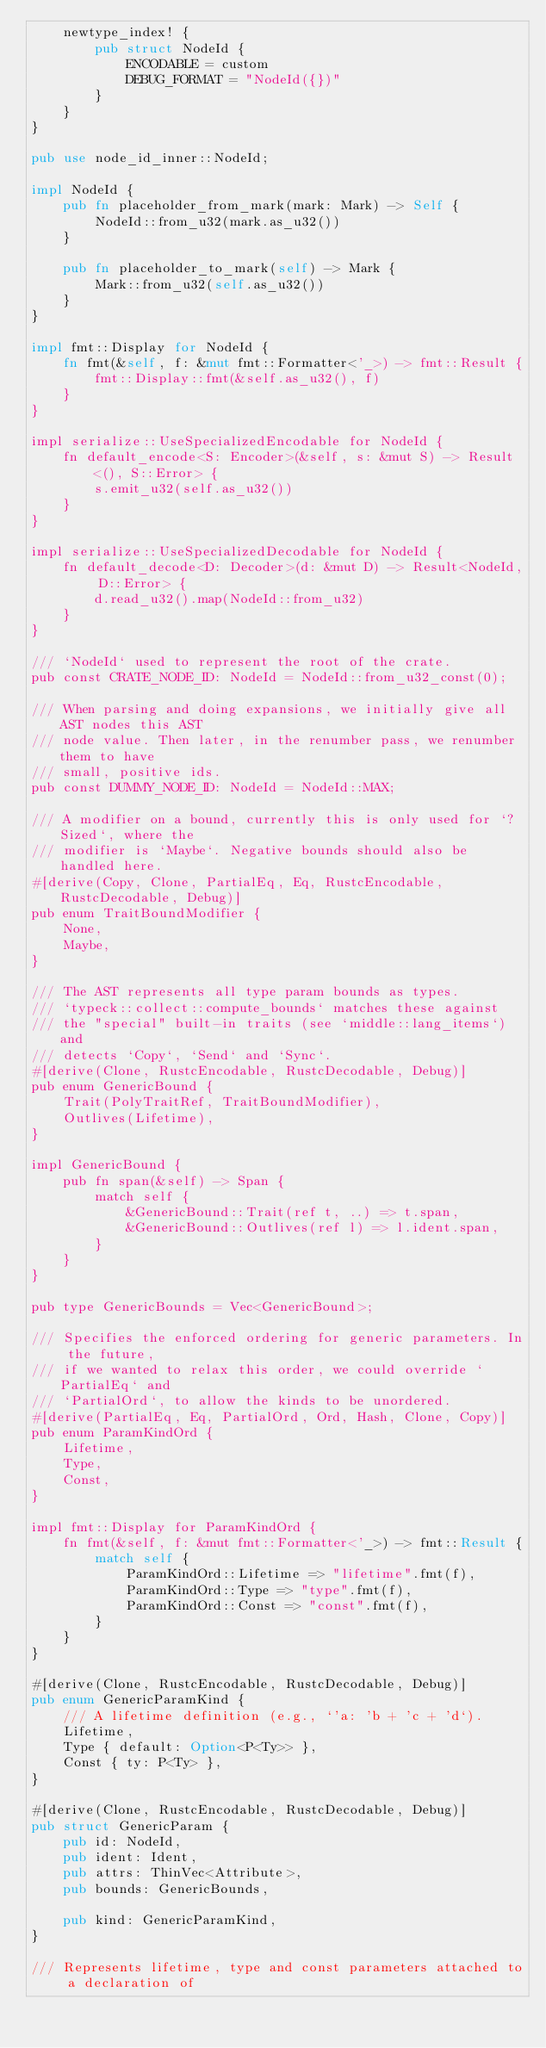Convert code to text. <code><loc_0><loc_0><loc_500><loc_500><_Rust_>    newtype_index! {
        pub struct NodeId {
            ENCODABLE = custom
            DEBUG_FORMAT = "NodeId({})"
        }
    }
}

pub use node_id_inner::NodeId;

impl NodeId {
    pub fn placeholder_from_mark(mark: Mark) -> Self {
        NodeId::from_u32(mark.as_u32())
    }

    pub fn placeholder_to_mark(self) -> Mark {
        Mark::from_u32(self.as_u32())
    }
}

impl fmt::Display for NodeId {
    fn fmt(&self, f: &mut fmt::Formatter<'_>) -> fmt::Result {
        fmt::Display::fmt(&self.as_u32(), f)
    }
}

impl serialize::UseSpecializedEncodable for NodeId {
    fn default_encode<S: Encoder>(&self, s: &mut S) -> Result<(), S::Error> {
        s.emit_u32(self.as_u32())
    }
}

impl serialize::UseSpecializedDecodable for NodeId {
    fn default_decode<D: Decoder>(d: &mut D) -> Result<NodeId, D::Error> {
        d.read_u32().map(NodeId::from_u32)
    }
}

/// `NodeId` used to represent the root of the crate.
pub const CRATE_NODE_ID: NodeId = NodeId::from_u32_const(0);

/// When parsing and doing expansions, we initially give all AST nodes this AST
/// node value. Then later, in the renumber pass, we renumber them to have
/// small, positive ids.
pub const DUMMY_NODE_ID: NodeId = NodeId::MAX;

/// A modifier on a bound, currently this is only used for `?Sized`, where the
/// modifier is `Maybe`. Negative bounds should also be handled here.
#[derive(Copy, Clone, PartialEq, Eq, RustcEncodable, RustcDecodable, Debug)]
pub enum TraitBoundModifier {
    None,
    Maybe,
}

/// The AST represents all type param bounds as types.
/// `typeck::collect::compute_bounds` matches these against
/// the "special" built-in traits (see `middle::lang_items`) and
/// detects `Copy`, `Send` and `Sync`.
#[derive(Clone, RustcEncodable, RustcDecodable, Debug)]
pub enum GenericBound {
    Trait(PolyTraitRef, TraitBoundModifier),
    Outlives(Lifetime),
}

impl GenericBound {
    pub fn span(&self) -> Span {
        match self {
            &GenericBound::Trait(ref t, ..) => t.span,
            &GenericBound::Outlives(ref l) => l.ident.span,
        }
    }
}

pub type GenericBounds = Vec<GenericBound>;

/// Specifies the enforced ordering for generic parameters. In the future,
/// if we wanted to relax this order, we could override `PartialEq` and
/// `PartialOrd`, to allow the kinds to be unordered.
#[derive(PartialEq, Eq, PartialOrd, Ord, Hash, Clone, Copy)]
pub enum ParamKindOrd {
    Lifetime,
    Type,
    Const,
}

impl fmt::Display for ParamKindOrd {
    fn fmt(&self, f: &mut fmt::Formatter<'_>) -> fmt::Result {
        match self {
            ParamKindOrd::Lifetime => "lifetime".fmt(f),
            ParamKindOrd::Type => "type".fmt(f),
            ParamKindOrd::Const => "const".fmt(f),
        }
    }
}

#[derive(Clone, RustcEncodable, RustcDecodable, Debug)]
pub enum GenericParamKind {
    /// A lifetime definition (e.g., `'a: 'b + 'c + 'd`).
    Lifetime,
    Type { default: Option<P<Ty>> },
    Const { ty: P<Ty> },
}

#[derive(Clone, RustcEncodable, RustcDecodable, Debug)]
pub struct GenericParam {
    pub id: NodeId,
    pub ident: Ident,
    pub attrs: ThinVec<Attribute>,
    pub bounds: GenericBounds,

    pub kind: GenericParamKind,
}

/// Represents lifetime, type and const parameters attached to a declaration of</code> 